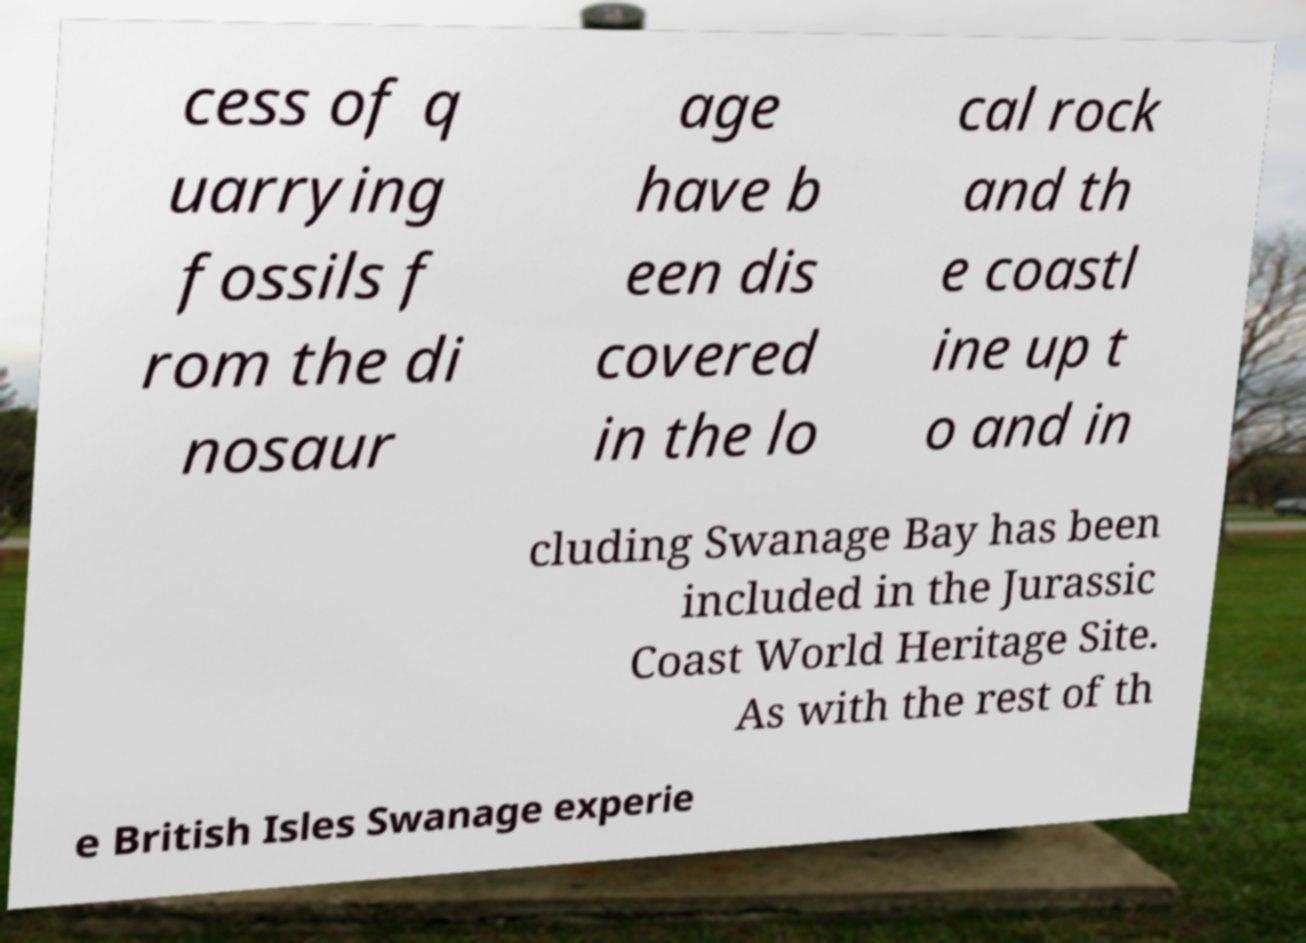Can you read and provide the text displayed in the image?This photo seems to have some interesting text. Can you extract and type it out for me? cess of q uarrying fossils f rom the di nosaur age have b een dis covered in the lo cal rock and th e coastl ine up t o and in cluding Swanage Bay has been included in the Jurassic Coast World Heritage Site. As with the rest of th e British Isles Swanage experie 